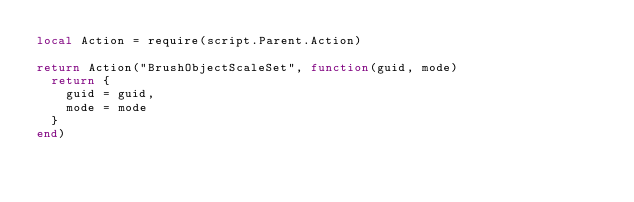<code> <loc_0><loc_0><loc_500><loc_500><_Lua_>local Action = require(script.Parent.Action)

return Action("BrushObjectScaleSet", function(guid, mode)
	return {
		guid = guid,
		mode = mode
	}
end)</code> 